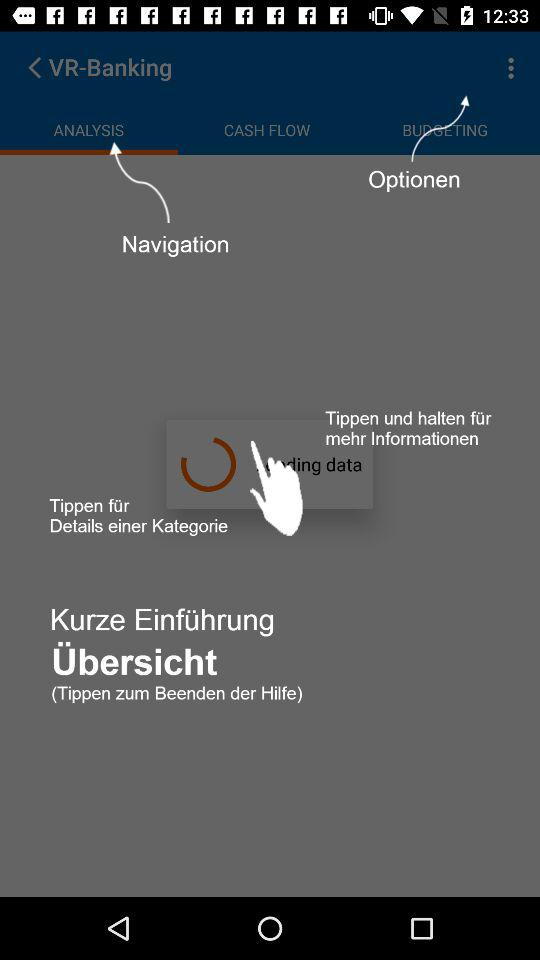Which tab am I on in "VR-Banking"? You are on the "ANALYSIS" tab in "VR-Banking". 